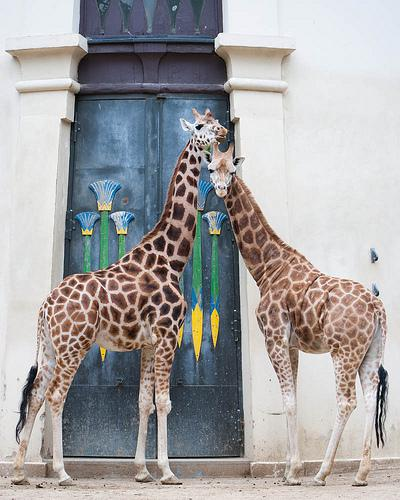Question: where is the yellow color?
Choices:
A. On the trim.
B. On the porch.
C. On the steps.
D. On the door.
Answer with the letter. Answer: D Question: what white objects beside the door?
Choices:
A. Statues.
B. Urns.
C. Tables.
D. Pillars.
Answer with the letter. Answer: D Question: where are the giraffes?
Choices:
A. Behind the building.
B. In the enclosed area.
C. In the field.
D. In front of the building.
Answer with the letter. Answer: D Question: how many giraffes?
Choices:
A. Three.
B. Two.
C. Four.
D. Five.
Answer with the letter. Answer: B Question: what is the main color of the door?
Choices:
A. Red.
B. Blue.
C. Green.
D. Black.
Answer with the letter. Answer: B Question: what animal is taller?
Choices:
A. The one on the right.
B. The one in the middle.
C. The one in the background.
D. The one on the left.
Answer with the letter. Answer: D Question: what color are the animals?
Choices:
A. Black and gray.
B. Tan and orange.
C. Brown and white.
D. Yellow and blue.
Answer with the letter. Answer: C 